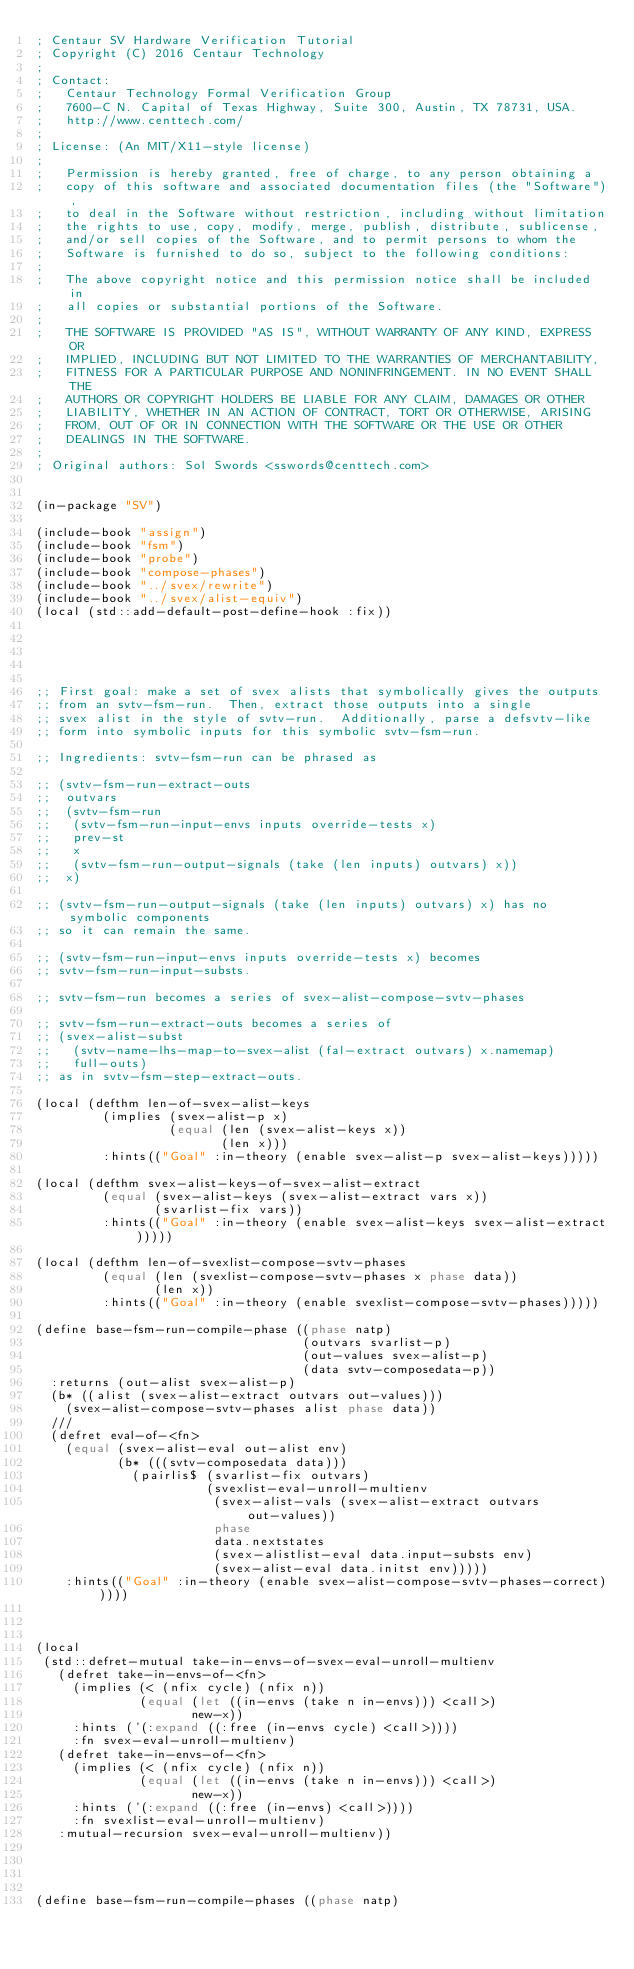<code> <loc_0><loc_0><loc_500><loc_500><_Lisp_>; Centaur SV Hardware Verification Tutorial
; Copyright (C) 2016 Centaur Technology
;
; Contact:
;   Centaur Technology Formal Verification Group
;   7600-C N. Capital of Texas Highway, Suite 300, Austin, TX 78731, USA.
;   http://www.centtech.com/
;
; License: (An MIT/X11-style license)
;
;   Permission is hereby granted, free of charge, to any person obtaining a
;   copy of this software and associated documentation files (the "Software"),
;   to deal in the Software without restriction, including without limitation
;   the rights to use, copy, modify, merge, publish, distribute, sublicense,
;   and/or sell copies of the Software, and to permit persons to whom the
;   Software is furnished to do so, subject to the following conditions:
;
;   The above copyright notice and this permission notice shall be included in
;   all copies or substantial portions of the Software.
;
;   THE SOFTWARE IS PROVIDED "AS IS", WITHOUT WARRANTY OF ANY KIND, EXPRESS OR
;   IMPLIED, INCLUDING BUT NOT LIMITED TO THE WARRANTIES OF MERCHANTABILITY,
;   FITNESS FOR A PARTICULAR PURPOSE AND NONINFRINGEMENT. IN NO EVENT SHALL THE
;   AUTHORS OR COPYRIGHT HOLDERS BE LIABLE FOR ANY CLAIM, DAMAGES OR OTHER
;   LIABILITY, WHETHER IN AN ACTION OF CONTRACT, TORT OR OTHERWISE, ARISING
;   FROM, OUT OF OR IN CONNECTION WITH THE SOFTWARE OR THE USE OR OTHER
;   DEALINGS IN THE SOFTWARE.
;
; Original authors: Sol Swords <sswords@centtech.com>


(in-package "SV")

(include-book "assign")
(include-book "fsm")
(include-book "probe")
(include-book "compose-phases")
(include-book "../svex/rewrite")
(include-book "../svex/alist-equiv")
(local (std::add-default-post-define-hook :fix))





;; First goal: make a set of svex alists that symbolically gives the outputs
;; from an svtv-fsm-run.  Then, extract those outputs into a single
;; svex alist in the style of svtv-run.  Additionally, parse a defsvtv-like
;; form into symbolic inputs for this symbolic svtv-fsm-run.

;; Ingredients: svtv-fsm-run can be phrased as

;; (svtv-fsm-run-extract-outs
;;  outvars
;;  (svtv-fsm-run
;;   (svtv-fsm-run-input-envs inputs override-tests x)
;;   prev-st
;;   x
;;   (svtv-fsm-run-output-signals (take (len inputs) outvars) x))
;;  x)

;; (svtv-fsm-run-output-signals (take (len inputs) outvars) x) has no symbolic components
;; so it can remain the same.

;; (svtv-fsm-run-input-envs inputs override-tests x) becomes
;; svtv-fsm-run-input-substs.

;; svtv-fsm-run becomes a series of svex-alist-compose-svtv-phases

;; svtv-fsm-run-extract-outs becomes a series of 
;; (svex-alist-subst
;;   (svtv-name-lhs-map-to-svex-alist (fal-extract outvars) x.namemap)
;;   full-outs)
;; as in svtv-fsm-step-extract-outs.

(local (defthm len-of-svex-alist-keys
         (implies (svex-alist-p x)
                  (equal (len (svex-alist-keys x))
                         (len x)))
         :hints(("Goal" :in-theory (enable svex-alist-p svex-alist-keys)))))

(local (defthm svex-alist-keys-of-svex-alist-extract
         (equal (svex-alist-keys (svex-alist-extract vars x))
                (svarlist-fix vars))
         :hints(("Goal" :in-theory (enable svex-alist-keys svex-alist-extract)))))

(local (defthm len-of-svexlist-compose-svtv-phases
         (equal (len (svexlist-compose-svtv-phases x phase data))
                (len x))
         :hints(("Goal" :in-theory (enable svexlist-compose-svtv-phases)))))

(define base-fsm-run-compile-phase ((phase natp)
                                    (outvars svarlist-p)
                                    (out-values svex-alist-p)
                                    (data svtv-composedata-p))
  :returns (out-alist svex-alist-p)
  (b* ((alist (svex-alist-extract outvars out-values)))
    (svex-alist-compose-svtv-phases alist phase data))
  ///
  (defret eval-of-<fn>
    (equal (svex-alist-eval out-alist env)
           (b* (((svtv-composedata data)))
             (pairlis$ (svarlist-fix outvars)
                       (svexlist-eval-unroll-multienv
                        (svex-alist-vals (svex-alist-extract outvars out-values))
                        phase
                        data.nextstates
                        (svex-alistlist-eval data.input-substs env)
                        (svex-alist-eval data.initst env)))))
    :hints(("Goal" :in-theory (enable svex-alist-compose-svtv-phases-correct)))))



(local
 (std::defret-mutual take-in-envs-of-svex-eval-unroll-multienv
   (defret take-in-envs-of-<fn>
     (implies (< (nfix cycle) (nfix n))
              (equal (let ((in-envs (take n in-envs))) <call>)
                     new-x))
     :hints ('(:expand ((:free (in-envs cycle) <call>))))
     :fn svex-eval-unroll-multienv)
   (defret take-in-envs-of-<fn>
     (implies (< (nfix cycle) (nfix n))
              (equal (let ((in-envs (take n in-envs))) <call>)
                     new-x))
     :hints ('(:expand ((:free (in-envs) <call>))))
     :fn svexlist-eval-unroll-multienv)
   :mutual-recursion svex-eval-unroll-multienv))
            
            


(define base-fsm-run-compile-phases ((phase natp)</code> 